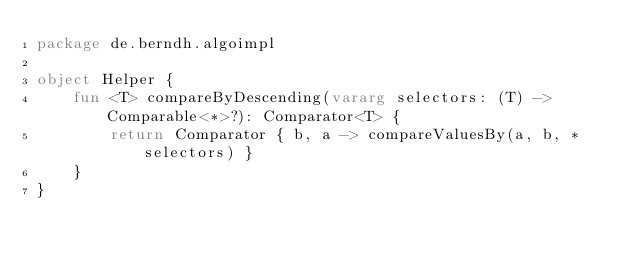<code> <loc_0><loc_0><loc_500><loc_500><_Kotlin_>package de.berndh.algoimpl

object Helper {
    fun <T> compareByDescending(vararg selectors: (T) -> Comparable<*>?): Comparator<T> {
        return Comparator { b, a -> compareValuesBy(a, b, *selectors) }
    }
}
</code> 